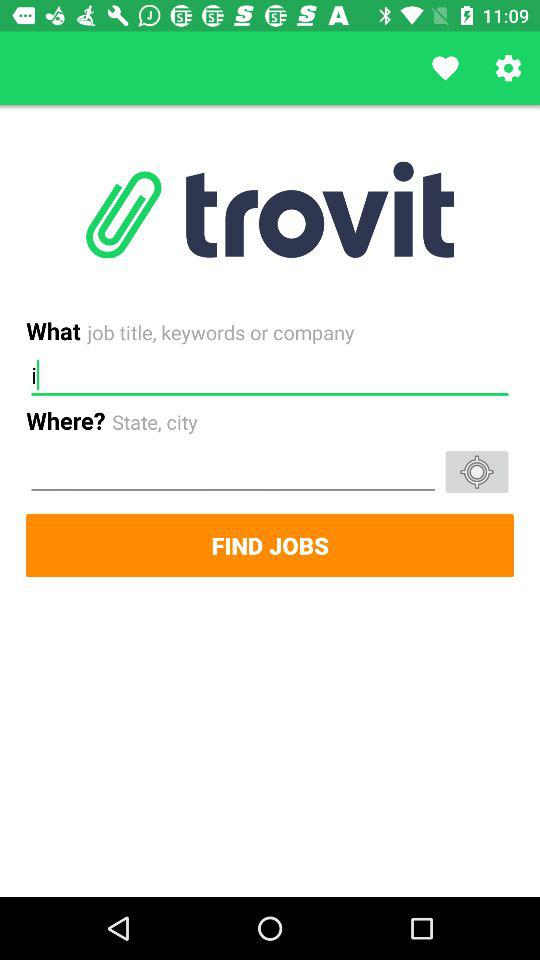What time is left for sunset? The time left for sunset is 07:43:48. 